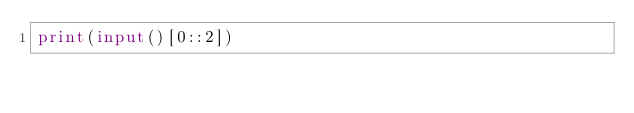<code> <loc_0><loc_0><loc_500><loc_500><_Python_>print(input()[0::2])
</code> 